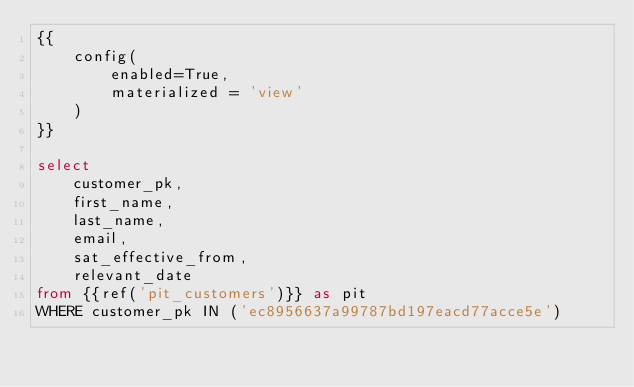<code> <loc_0><loc_0><loc_500><loc_500><_SQL_>{{
    config(
        enabled=True,
        materialized = 'view'
    )
}}

select
    customer_pk,
    first_name,
    last_name,
    email,
    sat_effective_from,
    relevant_date
from {{ref('pit_customers')}} as pit
WHERE customer_pk IN ('ec8956637a99787bd197eacd77acce5e')
</code> 